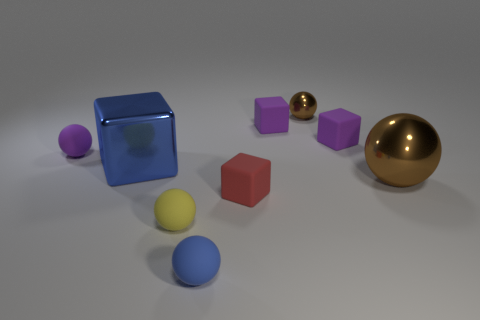How many purple cubes must be subtracted to get 1 purple cubes? 1 Subtract 1 balls. How many balls are left? 4 Subtract all blue spheres. How many spheres are left? 4 Subtract all tiny brown metallic spheres. How many spheres are left? 4 Subtract all cyan spheres. Subtract all blue blocks. How many spheres are left? 5 Add 1 small cubes. How many objects exist? 10 Subtract all cubes. How many objects are left? 5 Add 1 tiny purple balls. How many tiny purple balls are left? 2 Add 3 large purple metal balls. How many large purple metal balls exist? 3 Subtract 0 cyan balls. How many objects are left? 9 